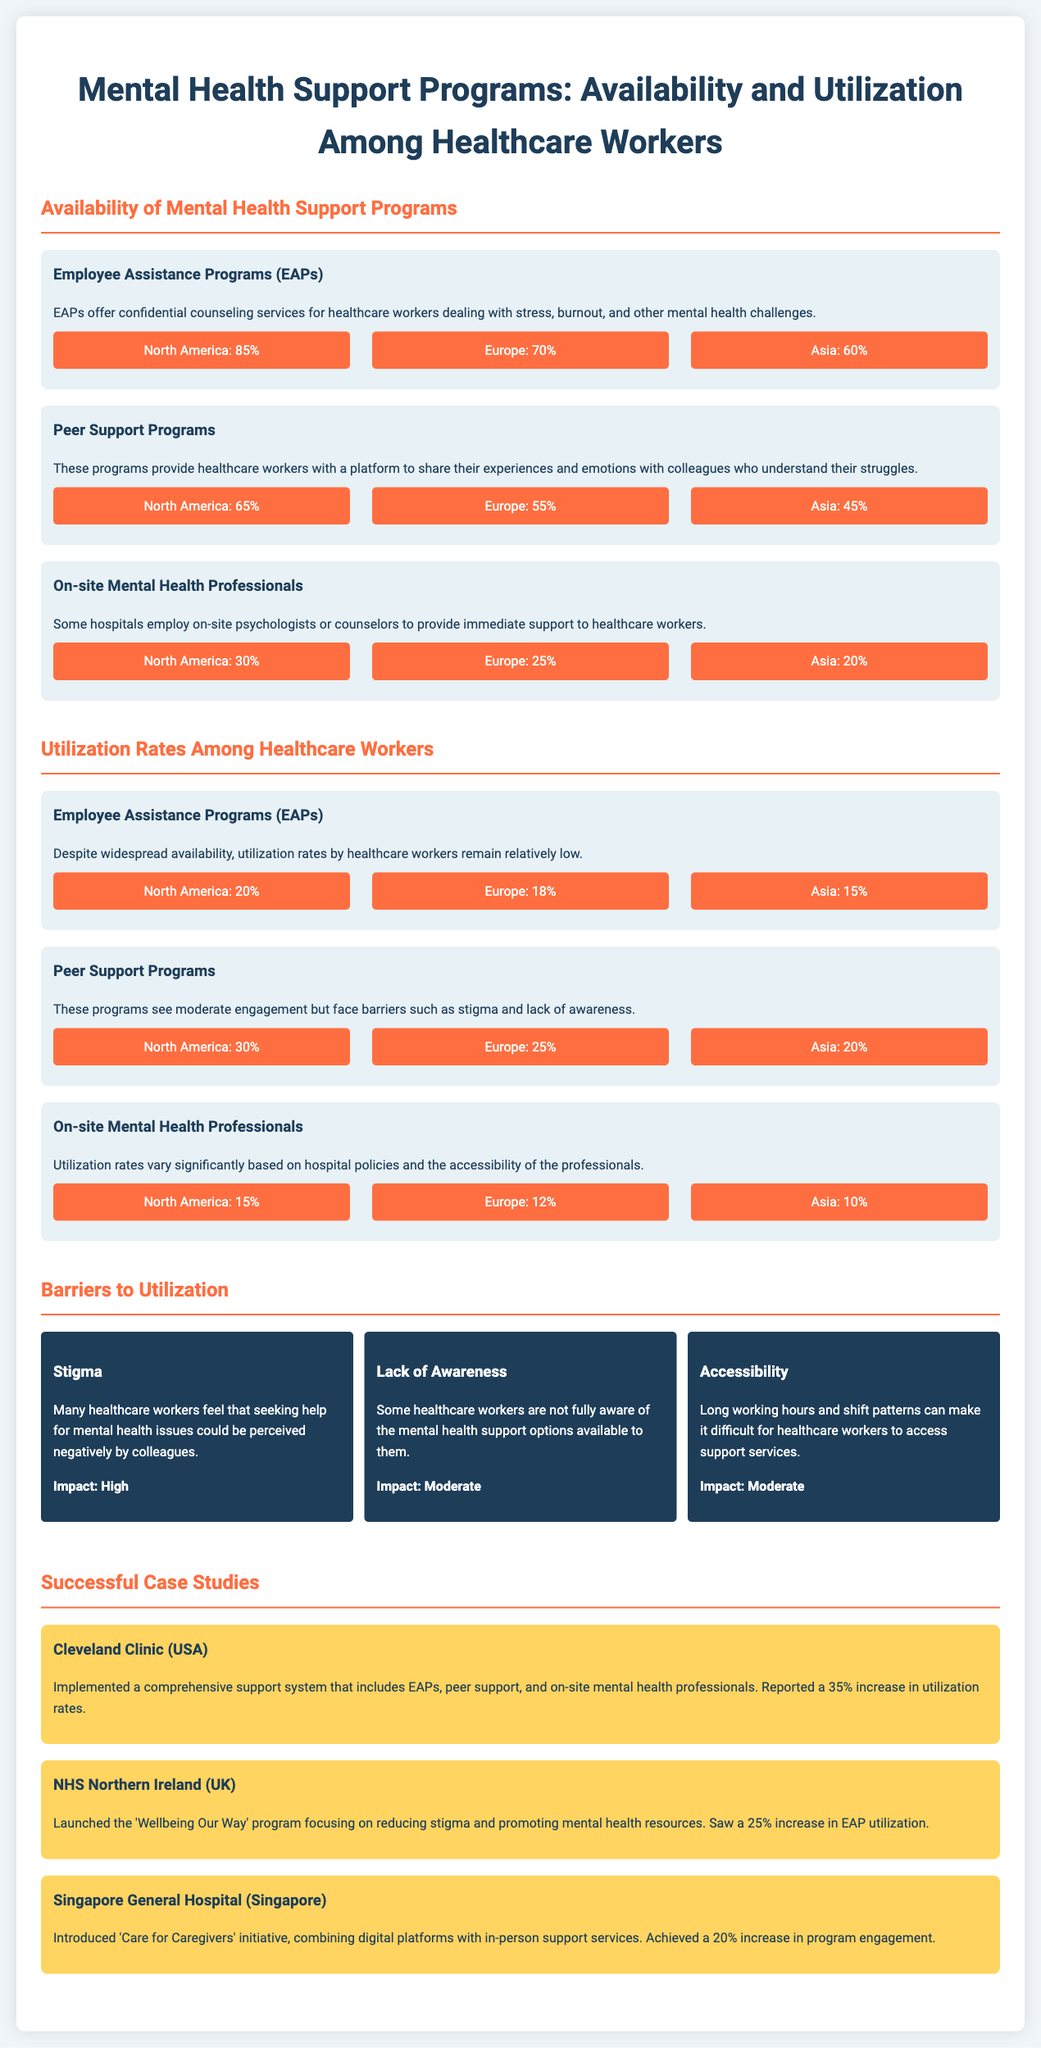What percentage of healthcare workers in North America have access to Employee Assistance Programs? The document states that 85% of healthcare workers in North America have access to Employee Assistance Programs.
Answer: 85% What is the utilization rate of Peer Support Programs in Europe? According to the document, the utilization rate of Peer Support Programs in Europe is 25%.
Answer: 25% What barrier to utilization has a high impact? The document identifies stigma as a barrier to utilization that has a high impact.
Answer: Stigma Which hospital implemented a comprehensive support system and reported a 35% increase in utilization rates? The document states that Cleveland Clinic (USA) implemented such a support system and reported a 35% increase in utilization rates.
Answer: Cleveland Clinic (USA) What is the percentage of healthcare workers in Asia accessing on-site mental health professionals? The document indicates that 20% of healthcare workers in Asia have access to on-site mental health professionals.
Answer: 20% What percentage of healthcare workers in North America utilize Employee Assistance Programs? It is stated in the document that 20% of healthcare workers in North America utilize Employee Assistance Programs.
Answer: 20% Which initiative was introduced at Singapore General Hospital to improve program engagement? The document mentions the 'Care for Caregivers' initiative as the one introduced at Singapore General Hospital to improve program engagement.
Answer: Care for Caregivers How does the availability of Peer Support Programs compare between North America and Asia? The document reveals availability rates for Peer Support Programs as 65% in North America and 45% in Asia, indicating higher availability in North America.
Answer: Higher availability in North America What percentage of healthcare workers in North America are aware of mental health support options? The document does not provide a specific percentage for awareness but lists lack of awareness as a barrier with a moderate impact.
Answer: Moderate impact 